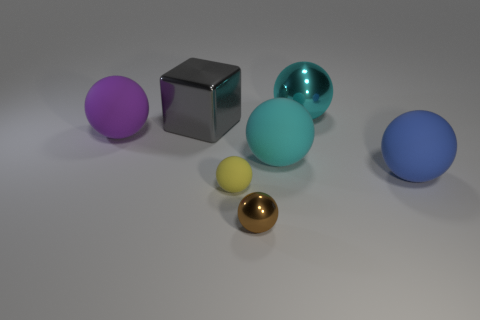Subtract all tiny rubber balls. How many balls are left? 5 Subtract all brown cylinders. How many cyan balls are left? 2 Add 1 cyan shiny balls. How many objects exist? 8 Subtract all purple spheres. How many spheres are left? 5 Subtract all balls. How many objects are left? 1 Subtract all yellow blocks. Subtract all green balls. How many blocks are left? 1 Subtract all blocks. Subtract all small yellow spheres. How many objects are left? 5 Add 5 small yellow things. How many small yellow things are left? 6 Add 6 tiny purple shiny objects. How many tiny purple shiny objects exist? 6 Subtract 0 brown cylinders. How many objects are left? 7 